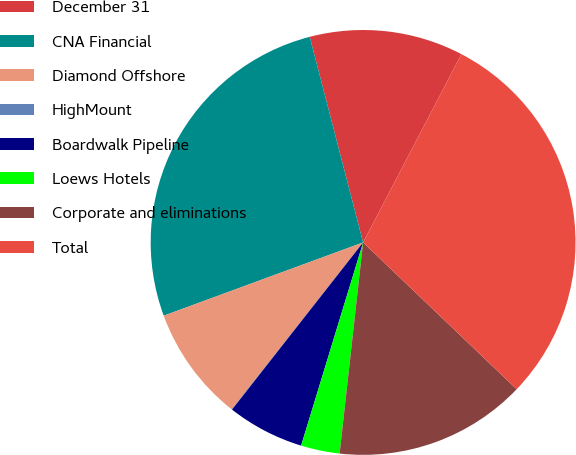<chart> <loc_0><loc_0><loc_500><loc_500><pie_chart><fcel>December 31<fcel>CNA Financial<fcel>Diamond Offshore<fcel>HighMount<fcel>Boardwalk Pipeline<fcel>Loews Hotels<fcel>Corporate and eliminations<fcel>Total<nl><fcel>11.7%<fcel>26.56%<fcel>8.78%<fcel>0.03%<fcel>5.87%<fcel>2.95%<fcel>14.62%<fcel>29.48%<nl></chart> 